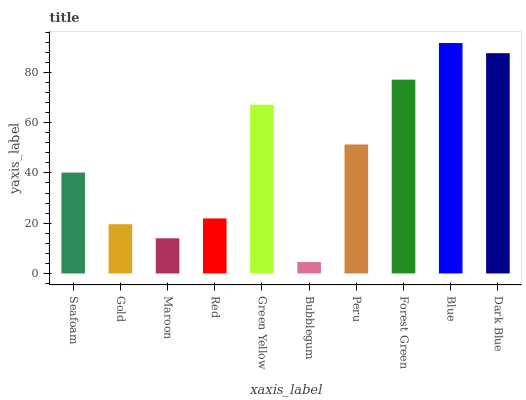Is Bubblegum the minimum?
Answer yes or no. Yes. Is Blue the maximum?
Answer yes or no. Yes. Is Gold the minimum?
Answer yes or no. No. Is Gold the maximum?
Answer yes or no. No. Is Seafoam greater than Gold?
Answer yes or no. Yes. Is Gold less than Seafoam?
Answer yes or no. Yes. Is Gold greater than Seafoam?
Answer yes or no. No. Is Seafoam less than Gold?
Answer yes or no. No. Is Peru the high median?
Answer yes or no. Yes. Is Seafoam the low median?
Answer yes or no. Yes. Is Gold the high median?
Answer yes or no. No. Is Green Yellow the low median?
Answer yes or no. No. 